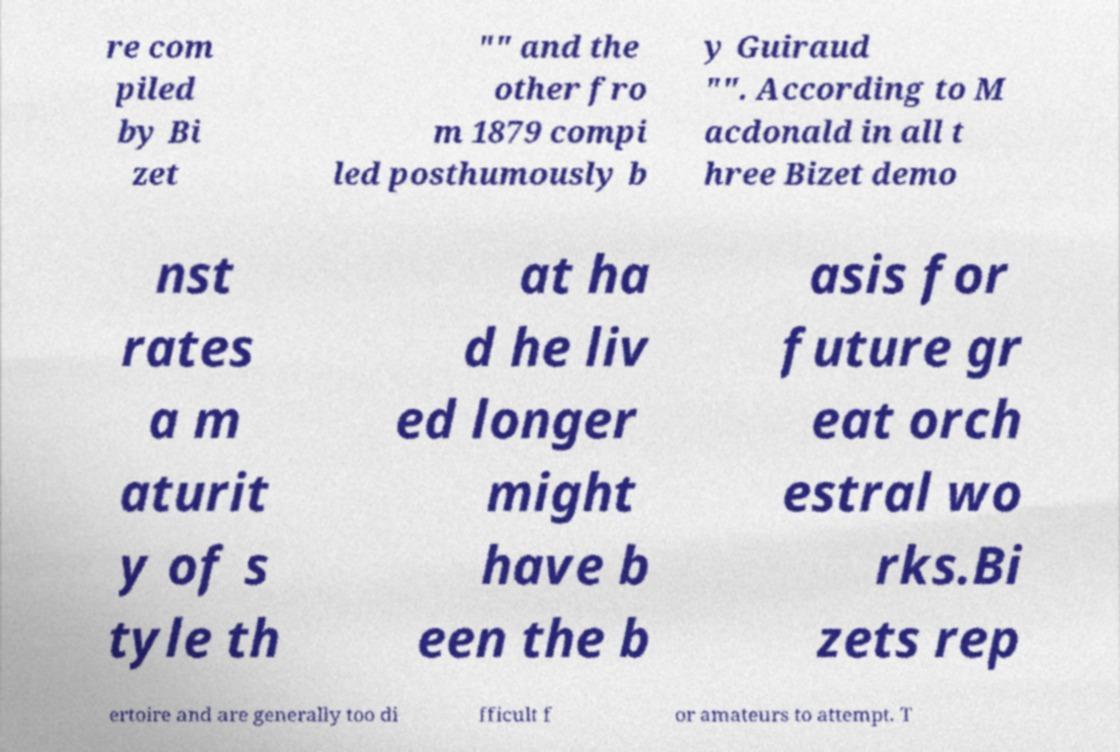There's text embedded in this image that I need extracted. Can you transcribe it verbatim? re com piled by Bi zet "" and the other fro m 1879 compi led posthumously b y Guiraud "". According to M acdonald in all t hree Bizet demo nst rates a m aturit y of s tyle th at ha d he liv ed longer might have b een the b asis for future gr eat orch estral wo rks.Bi zets rep ertoire and are generally too di fficult f or amateurs to attempt. T 